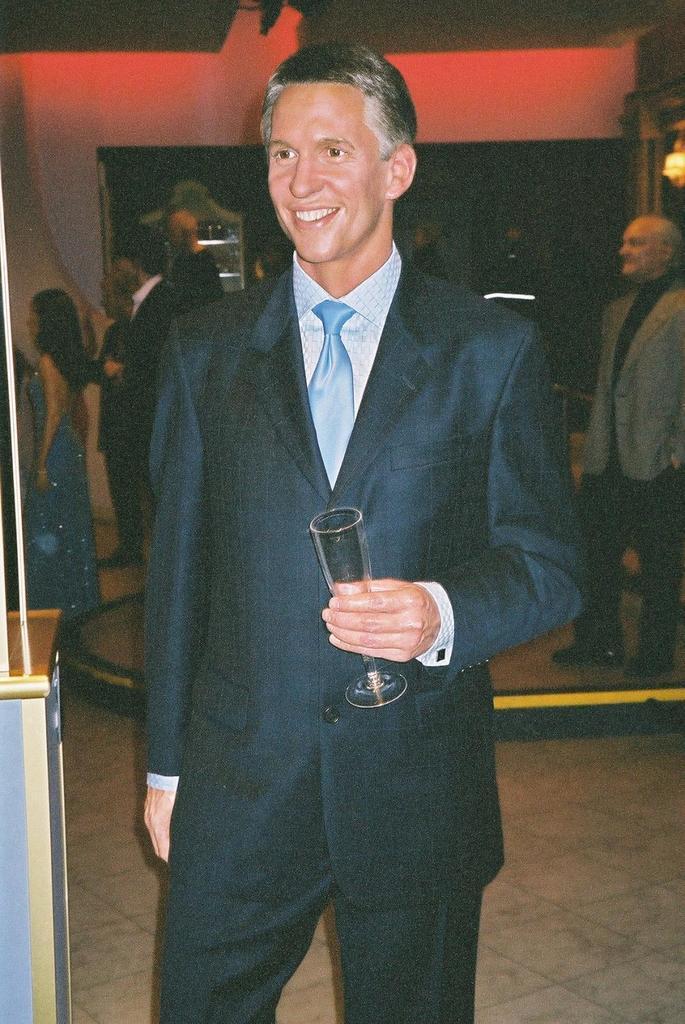Please provide a concise description of this image. In this picture there is a person standing and smiling and he is holding the glass. At the back there are group of people and at the top there is a light and there are objects in the cupboard. On the left side of the image there is a table. 